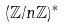Convert formula to latex. <formula><loc_0><loc_0><loc_500><loc_500>( \mathbb { Z } / n \mathbb { Z } ) ^ { * }</formula> 